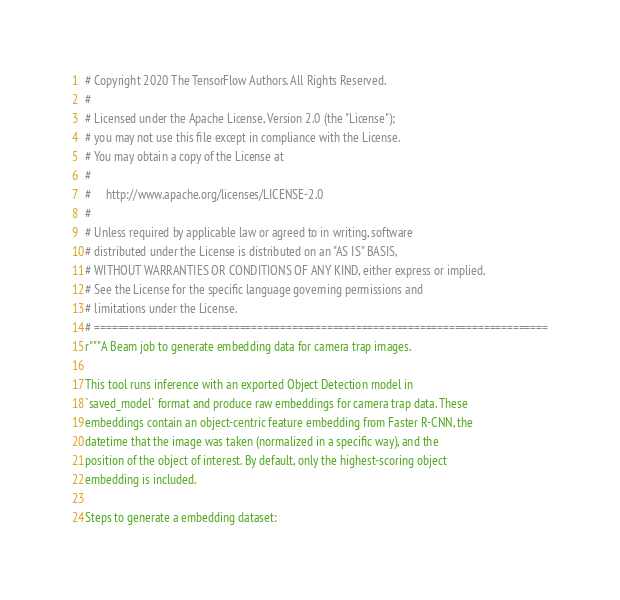Convert code to text. <code><loc_0><loc_0><loc_500><loc_500><_Python_># Copyright 2020 The TensorFlow Authors. All Rights Reserved.
#
# Licensed under the Apache License, Version 2.0 (the "License");
# you may not use this file except in compliance with the License.
# You may obtain a copy of the License at
#
#     http://www.apache.org/licenses/LICENSE-2.0
#
# Unless required by applicable law or agreed to in writing, software
# distributed under the License is distributed on an "AS IS" BASIS,
# WITHOUT WARRANTIES OR CONDITIONS OF ANY KIND, either express or implied.
# See the License for the specific language governing permissions and
# limitations under the License.
# ==============================================================================
r"""A Beam job to generate embedding data for camera trap images.

This tool runs inference with an exported Object Detection model in
`saved_model` format and produce raw embeddings for camera trap data. These
embeddings contain an object-centric feature embedding from Faster R-CNN, the
datetime that the image was taken (normalized in a specific way), and the
position of the object of interest. By default, only the highest-scoring object
embedding is included.

Steps to generate a embedding dataset:</code> 